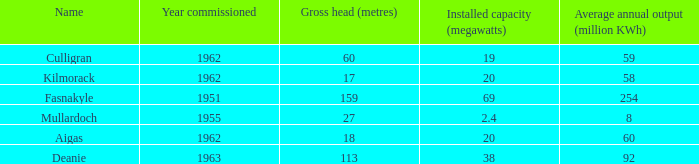What is the Year Commissioned of the power stationo with a Gross head of less than 18? 1962.0. 